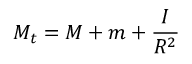Convert formula to latex. <formula><loc_0><loc_0><loc_500><loc_500>M _ { t } = M + m + { \frac { I } { R ^ { 2 } } }</formula> 